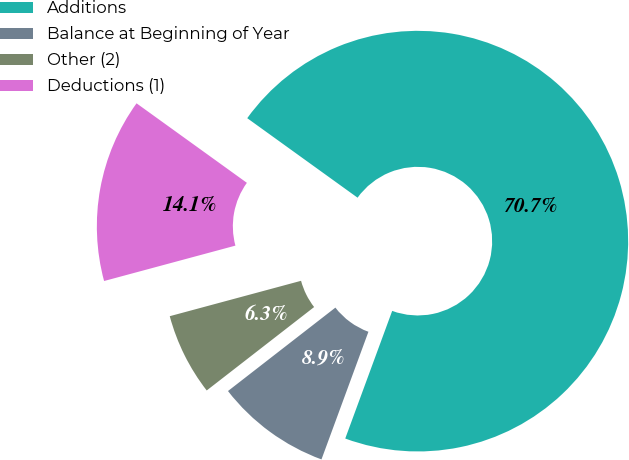Convert chart. <chart><loc_0><loc_0><loc_500><loc_500><pie_chart><fcel>Additions<fcel>Balance at Beginning of Year<fcel>Other (2)<fcel>Deductions (1)<nl><fcel>70.67%<fcel>8.88%<fcel>6.32%<fcel>14.13%<nl></chart> 